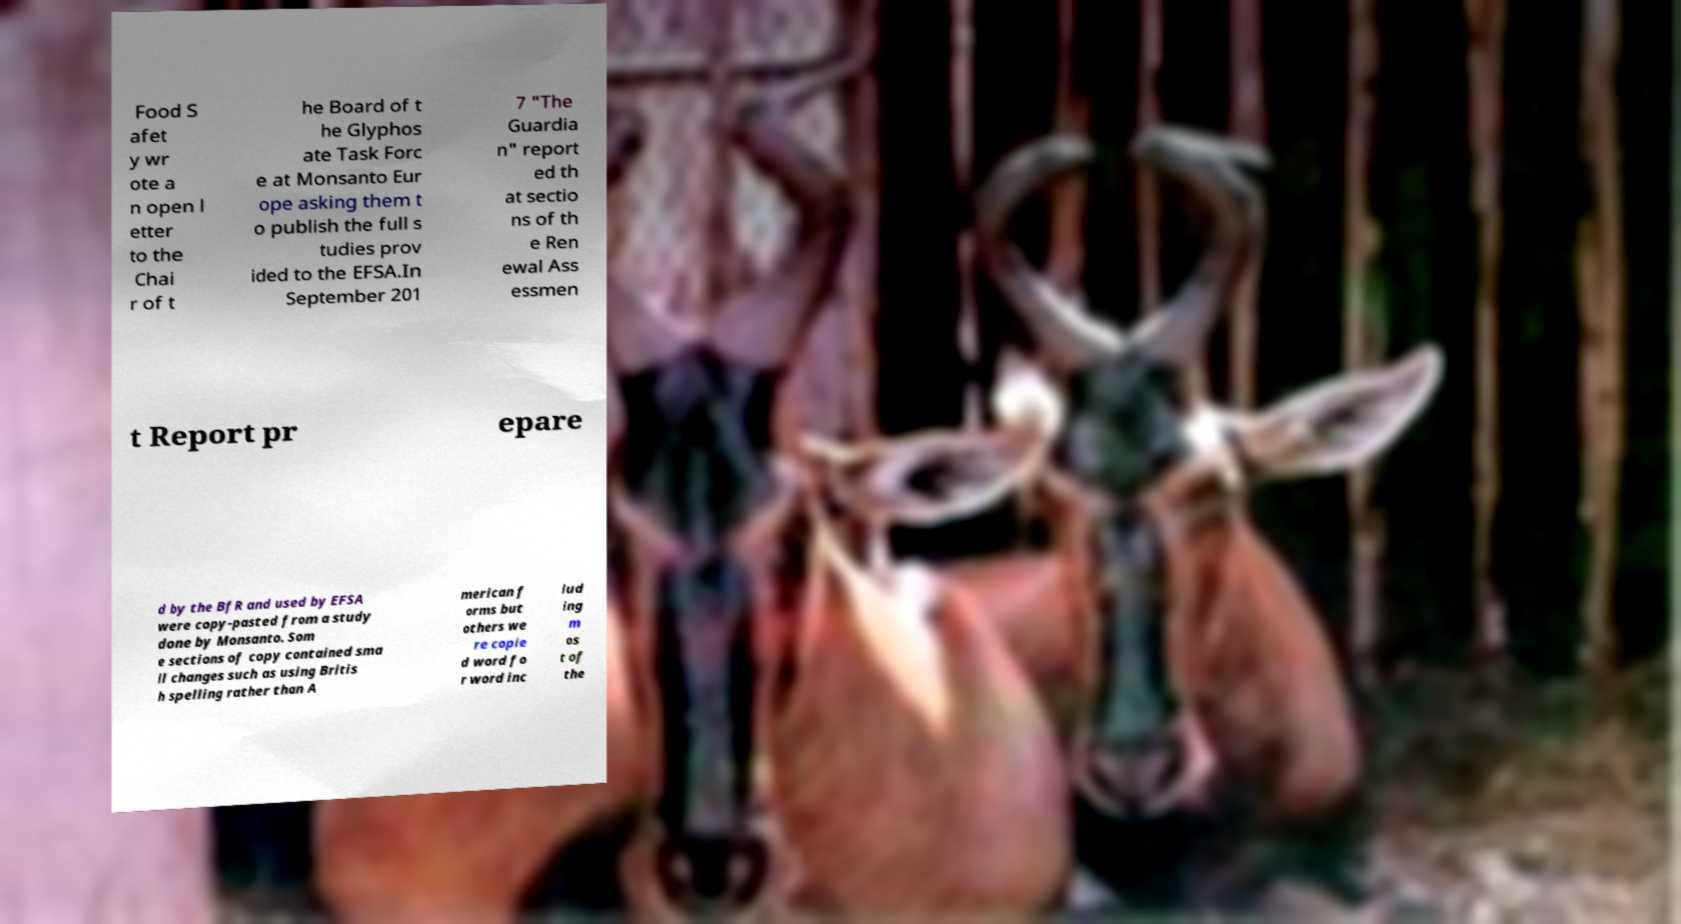Please identify and transcribe the text found in this image. Food S afet y wr ote a n open l etter to the Chai r of t he Board of t he Glyphos ate Task Forc e at Monsanto Eur ope asking them t o publish the full s tudies prov ided to the EFSA.In September 201 7 "The Guardia n" report ed th at sectio ns of th e Ren ewal Ass essmen t Report pr epare d by the BfR and used by EFSA were copy-pasted from a study done by Monsanto. Som e sections of copy contained sma ll changes such as using Britis h spelling rather than A merican f orms but others we re copie d word fo r word inc lud ing m os t of the 